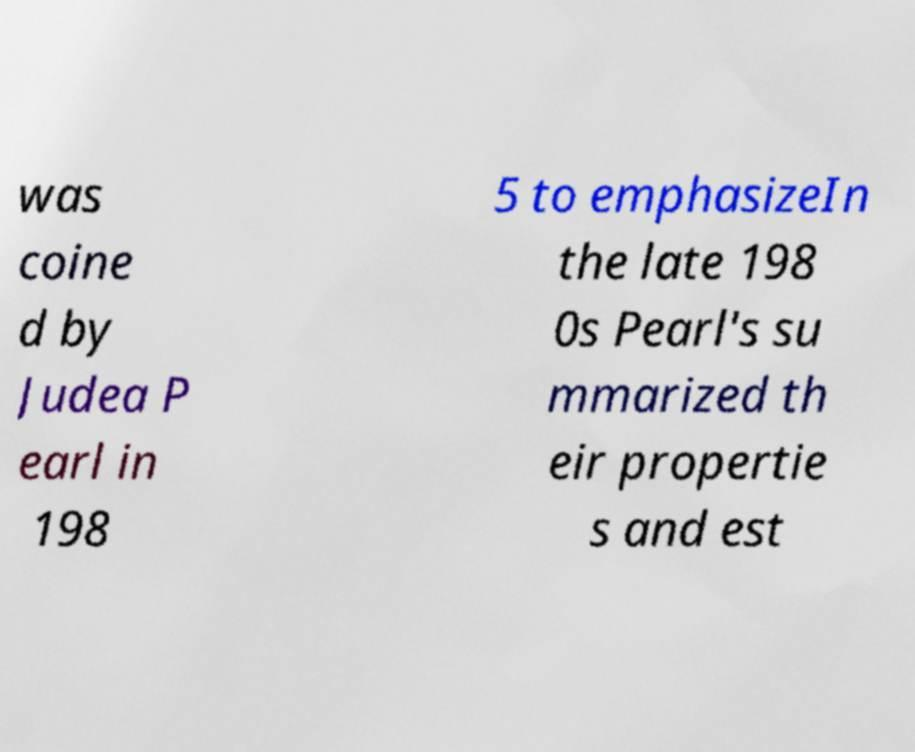Could you extract and type out the text from this image? was coine d by Judea P earl in 198 5 to emphasizeIn the late 198 0s Pearl's su mmarized th eir propertie s and est 